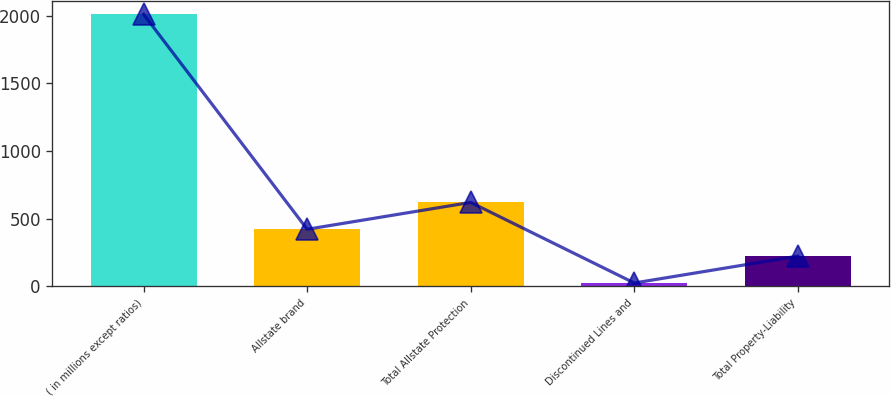Convert chart to OTSL. <chart><loc_0><loc_0><loc_500><loc_500><bar_chart><fcel>( in millions except ratios)<fcel>Allstate brand<fcel>Total Allstate Protection<fcel>Discontinued Lines and<fcel>Total Property-Liability<nl><fcel>2009<fcel>421<fcel>619.5<fcel>24<fcel>222.5<nl></chart> 